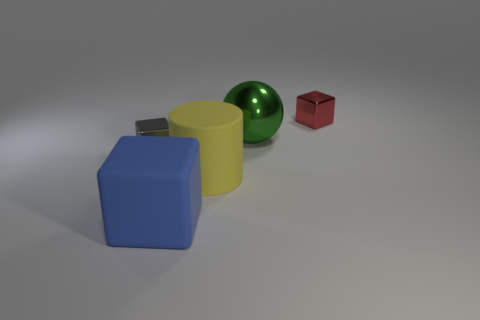There is another rubber object that is the same shape as the gray object; what is its size?
Keep it short and to the point. Large. Do the large rubber block and the matte cylinder have the same color?
Keep it short and to the point. No. What is the color of the big object that is both to the right of the blue object and in front of the big green metallic object?
Your answer should be very brief. Yellow. Is the size of the cube that is behind the ball the same as the large green metal sphere?
Keep it short and to the point. No. Is there anything else that has the same shape as the blue rubber object?
Keep it short and to the point. Yes. Is the tiny red block made of the same material as the small object that is on the left side of the ball?
Make the answer very short. Yes. What number of purple objects are either big rubber objects or metallic spheres?
Offer a very short reply. 0. Are any large gray objects visible?
Provide a short and direct response. No. There is a yellow matte cylinder that is right of the large blue rubber cube to the left of the large green metallic ball; is there a large cylinder right of it?
Your answer should be very brief. No. Is there any other thing that is the same size as the gray shiny block?
Offer a very short reply. Yes. 